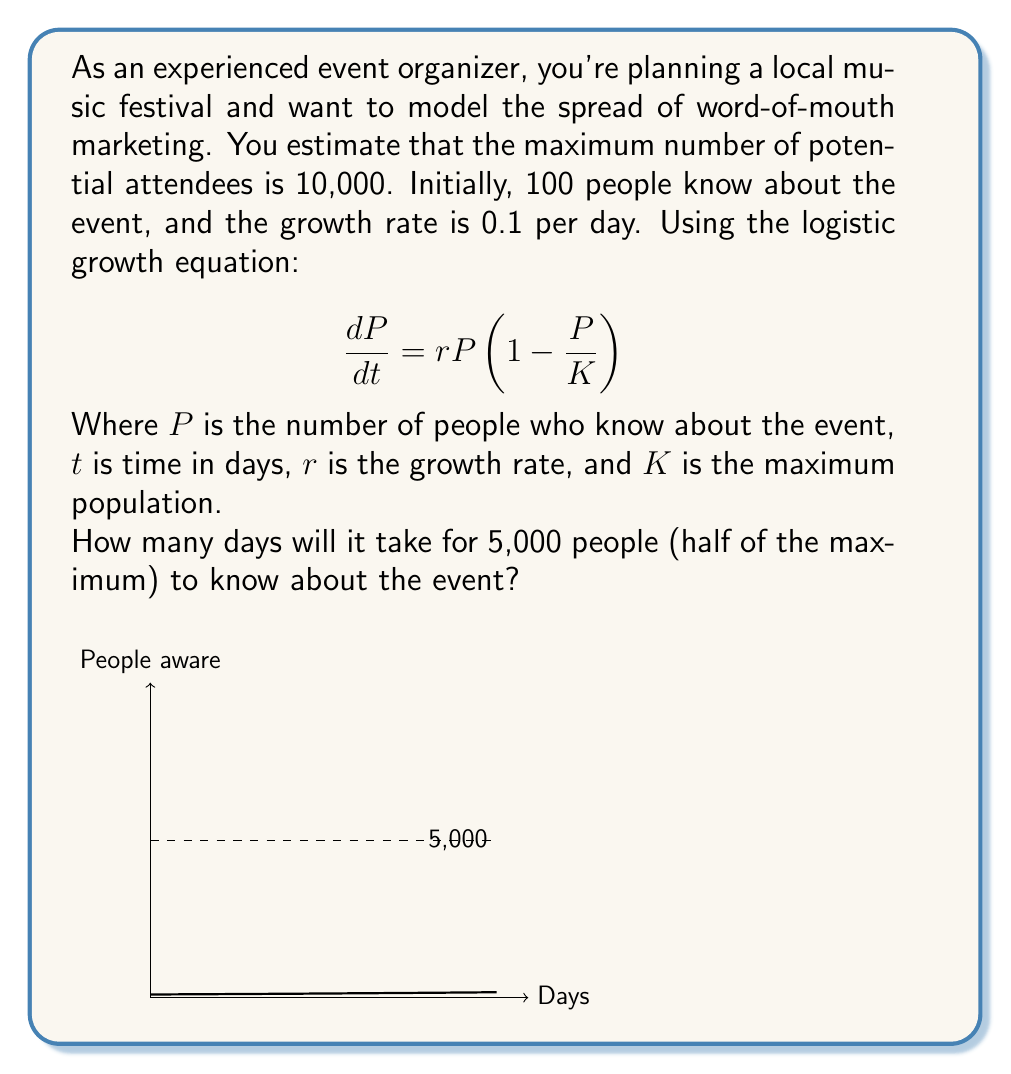Solve this math problem. Let's approach this step-by-step:

1) The logistic growth equation is given by:
   $$\frac{dP}{dt} = rP(1-\frac{P}{K})$$

2) The solution to this equation is:
   $$P(t) = \frac{K}{1 + (\frac{K}{P_0} - 1)e^{-rt}}$$

   Where $P_0$ is the initial population.

3) We're given:
   $K = 10,000$ (maximum population)
   $P_0 = 100$ (initial population)
   $r = 0.1$ (growth rate)

4) We want to find $t$ when $P(t) = 5,000$ (half of the maximum).

5) Substituting these values into the equation:

   $$5000 = \frac{10000}{1 + (\frac{10000}{100} - 1)e^{-0.1t}}$$

6) Simplify:
   $$5000 = \frac{10000}{1 + 99e^{-0.1t}}$$

7) Multiply both sides by $(1 + 99e^{-0.1t})$:
   $$5000(1 + 99e^{-0.1t}) = 10000$$

8) Distribute:
   $$5000 + 495000e^{-0.1t} = 10000$$

9) Subtract 5000 from both sides:
   $$495000e^{-0.1t} = 5000$$

10) Divide both sides by 495000:
    $$e^{-0.1t} = \frac{1}{99}$$

11) Take the natural log of both sides:
    $$-0.1t = \ln(\frac{1}{99})$$

12) Divide both sides by -0.1:
    $$t = -10\ln(\frac{1}{99}) \approx 46.05$$

Therefore, it will take approximately 46 days for 5,000 people to know about the event.
Answer: $46$ days 